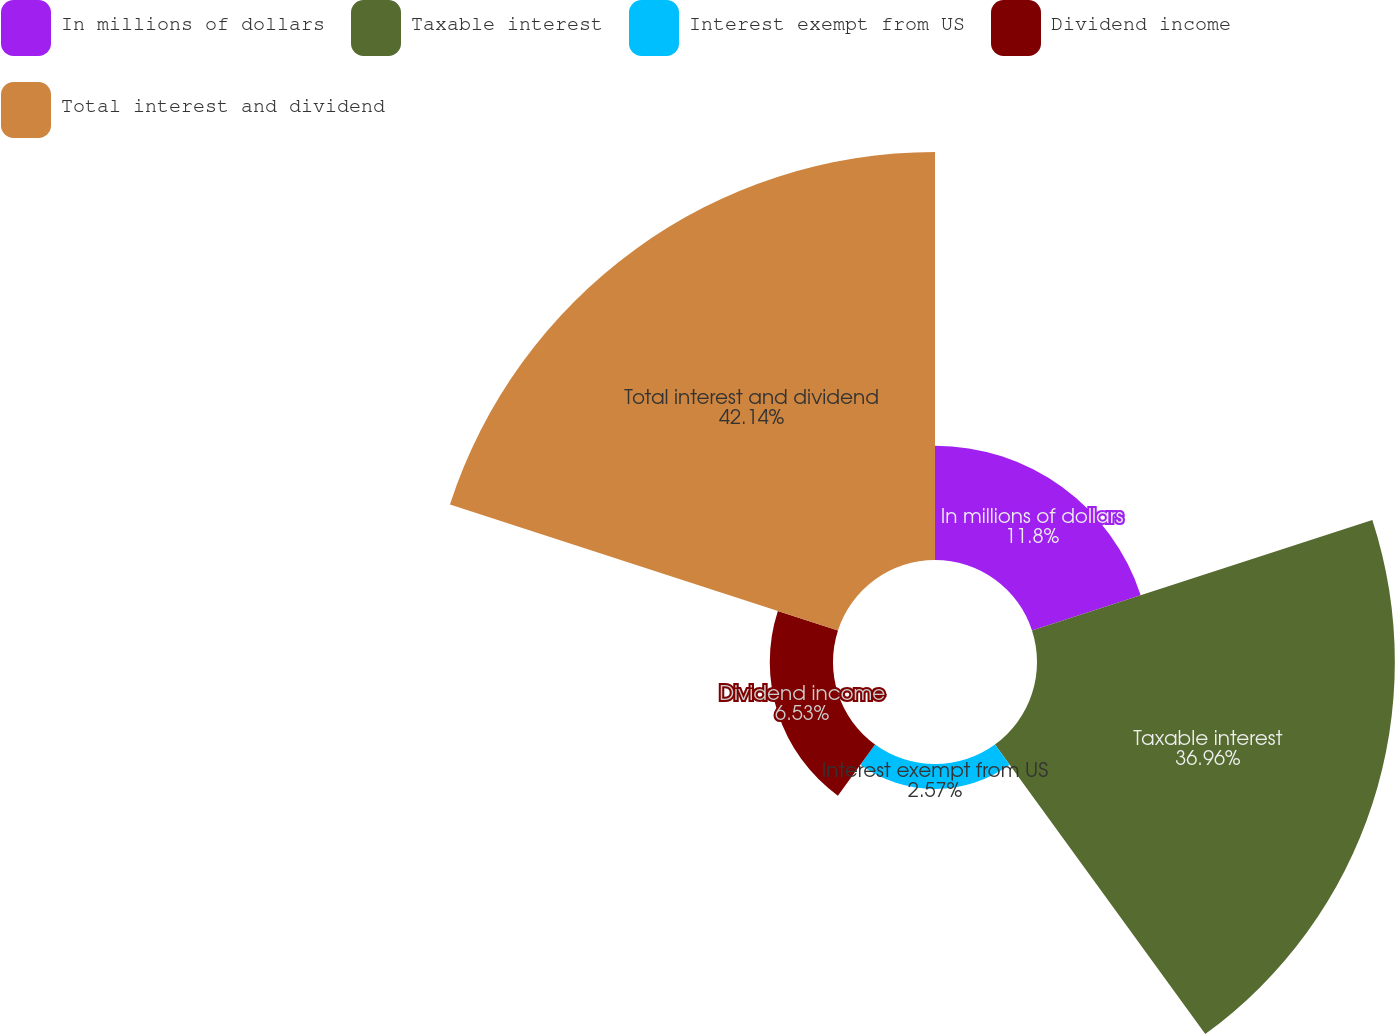Convert chart. <chart><loc_0><loc_0><loc_500><loc_500><pie_chart><fcel>In millions of dollars<fcel>Taxable interest<fcel>Interest exempt from US<fcel>Dividend income<fcel>Total interest and dividend<nl><fcel>11.8%<fcel>36.96%<fcel>2.57%<fcel>6.53%<fcel>42.14%<nl></chart> 